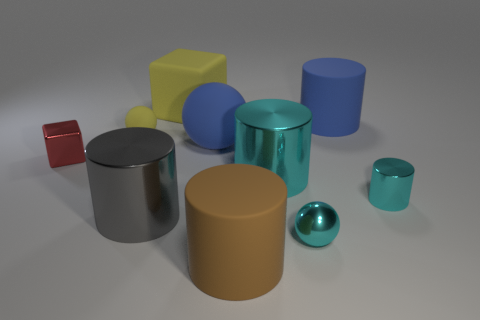There is a cylinder that is the same size as the metallic cube; what material is it?
Keep it short and to the point. Metal. Do the tiny red object and the large cyan thing have the same material?
Your answer should be compact. Yes. What number of small cyan balls are the same material as the big brown cylinder?
Your answer should be compact. 0. What number of objects are objects left of the large yellow rubber object or big cylinders in front of the tiny cube?
Offer a terse response. 5. Is the number of shiny objects that are left of the large ball greater than the number of cylinders on the left side of the yellow rubber cube?
Your answer should be very brief. Yes. What color is the rubber ball that is on the left side of the big yellow rubber thing?
Provide a succinct answer. Yellow. Are there any yellow rubber things that have the same shape as the large cyan object?
Make the answer very short. No. How many cyan things are either big spheres or small metal objects?
Your answer should be very brief. 2. Is there a blue matte cylinder of the same size as the brown rubber cylinder?
Give a very brief answer. Yes. How many big yellow metallic objects are there?
Your response must be concise. 0. 